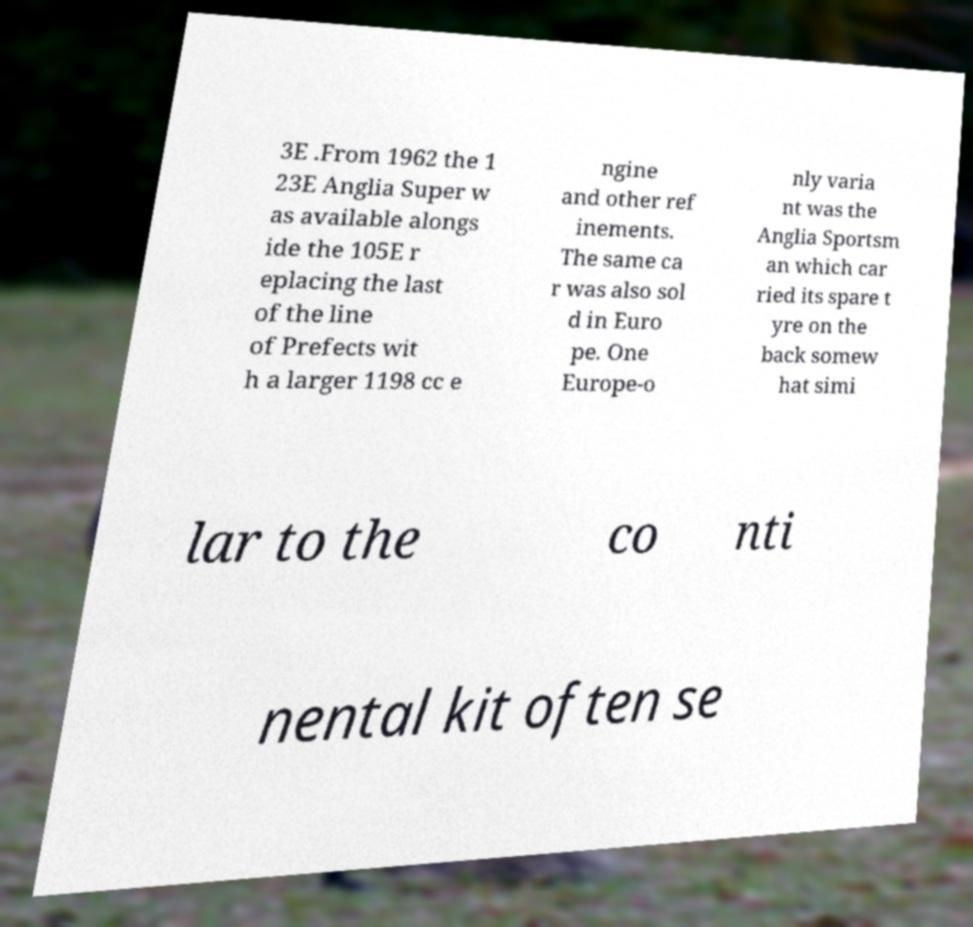What messages or text are displayed in this image? I need them in a readable, typed format. 3E .From 1962 the 1 23E Anglia Super w as available alongs ide the 105E r eplacing the last of the line of Prefects wit h a larger 1198 cc e ngine and other ref inements. The same ca r was also sol d in Euro pe. One Europe-o nly varia nt was the Anglia Sportsm an which car ried its spare t yre on the back somew hat simi lar to the co nti nental kit often se 